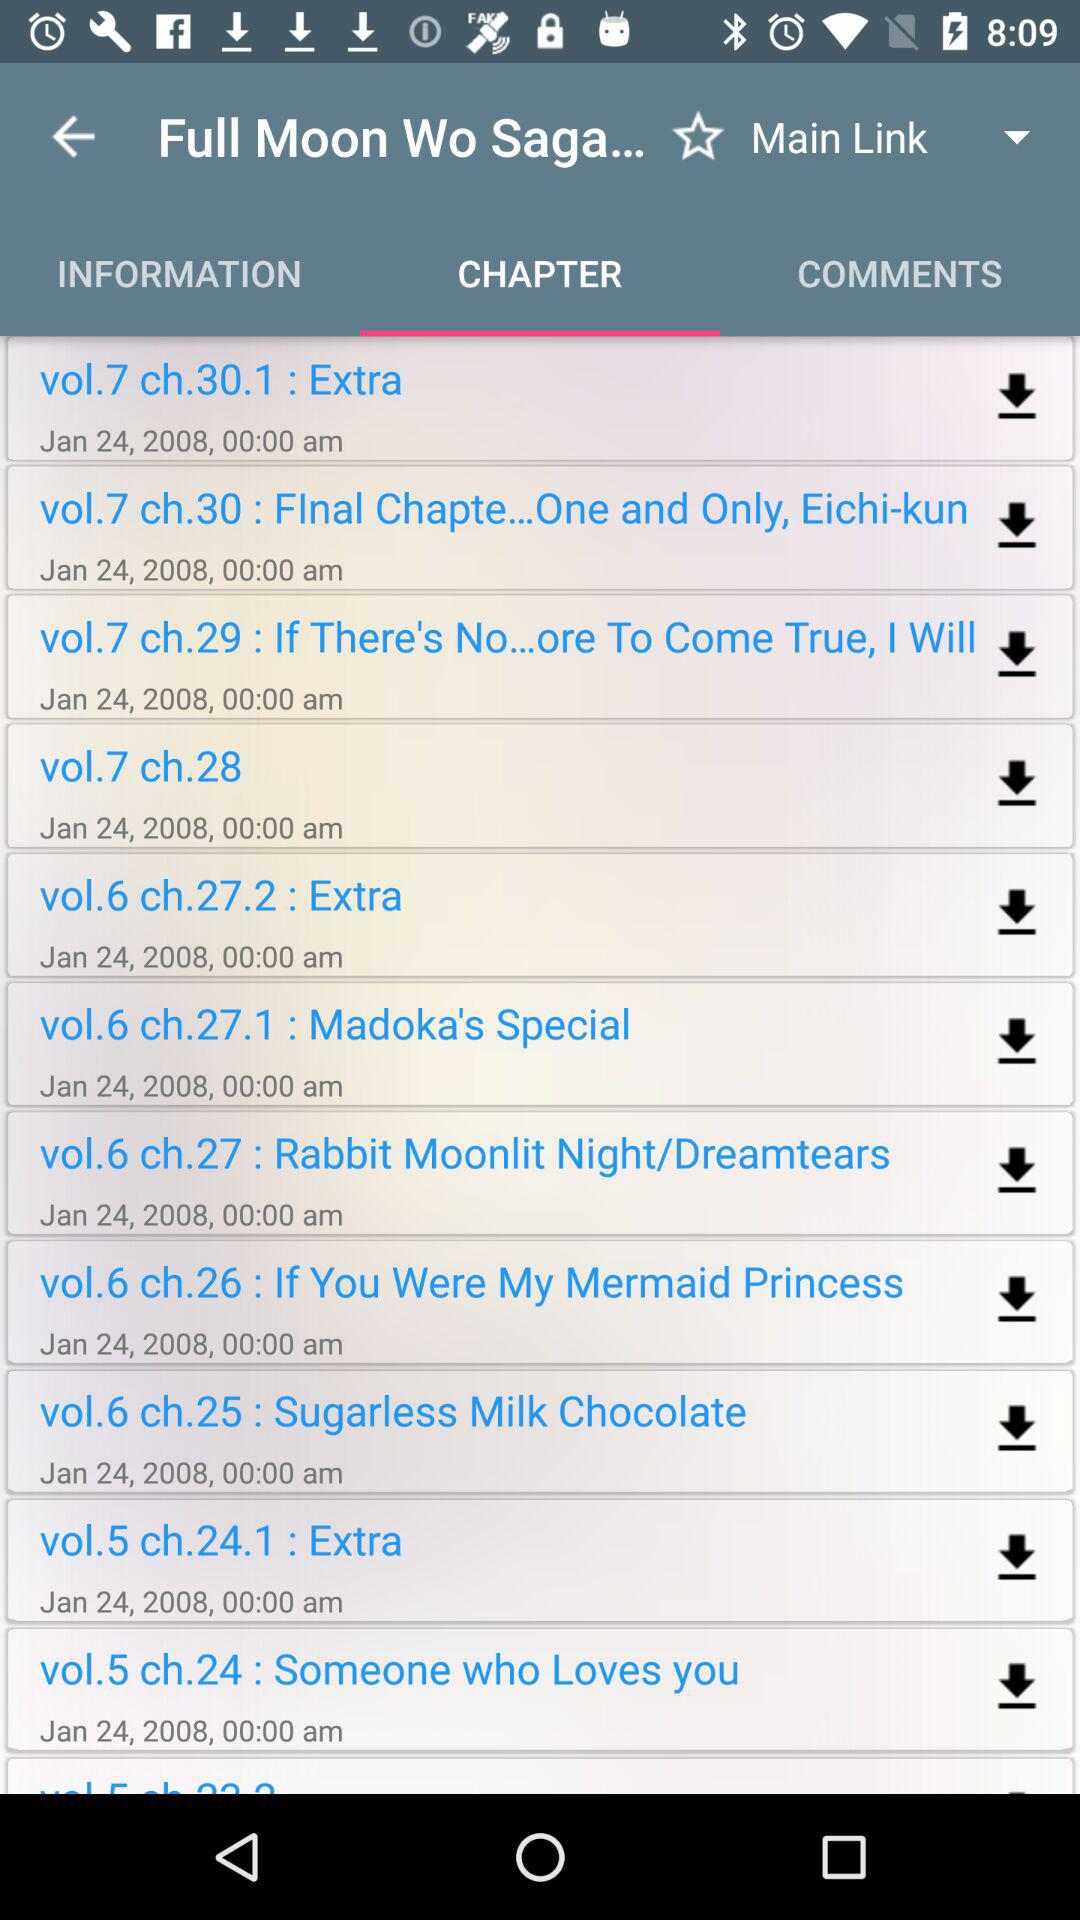Which tab is selected? The selected tab is "CHAPTER". 